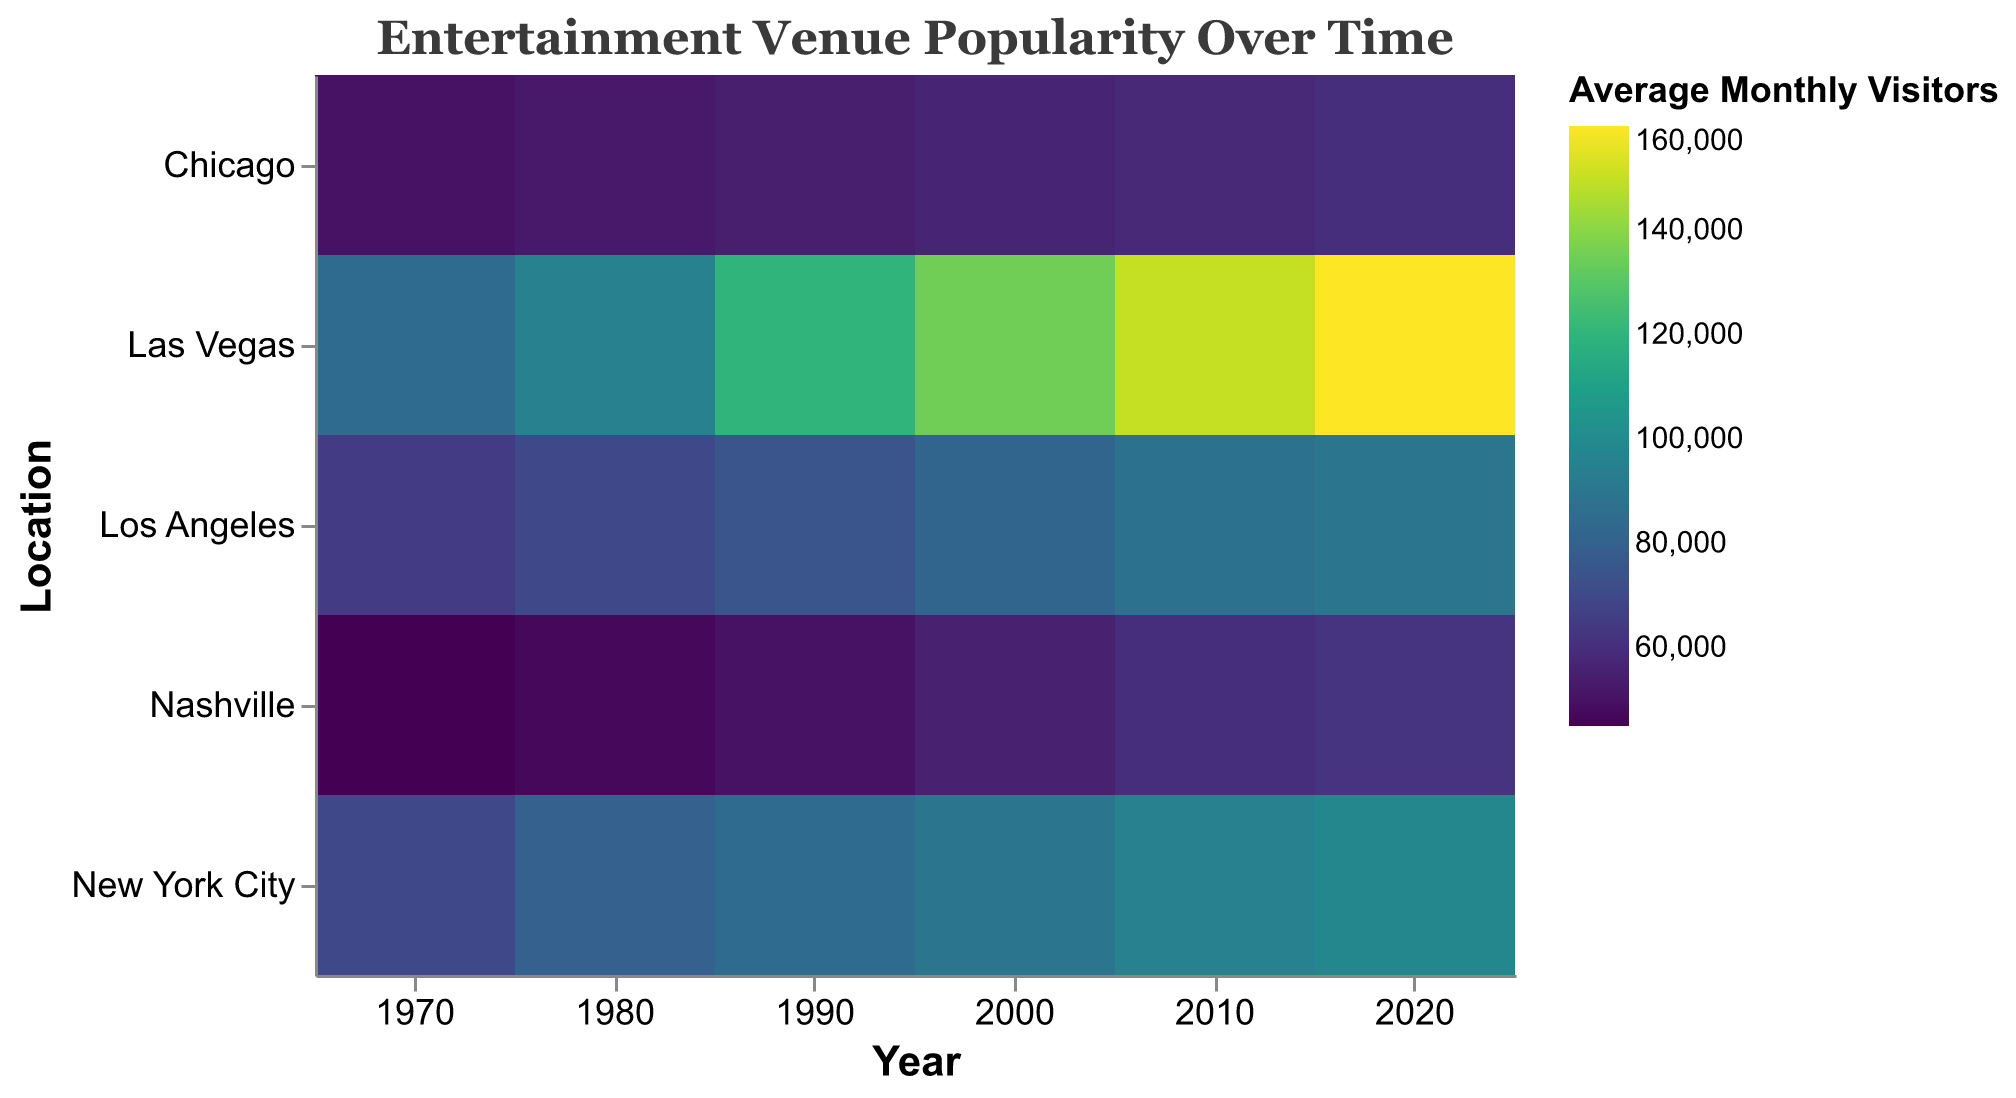How many geographic locations are represented in the heatmap? The heatmap shows rows labeled by geographic location, giving us the total number.
Answer: 5 What was the average monthly visitor count for Concert Venues in Los Angeles in 2010? Check the row for Los Angeles and the column for 2010, then identify the color intensity and corresponding visitor count in the legend.
Answer: 88,000 Which location had the highest increase in average monthly visitors from 1970 to 2020? Calculate the difference in average monthly visitors for each location from 1970 to 2020 and compare them.
Answer: Las Vegas Between New York City and Chicago, which location had more visitors in 1980? Compare the average monthly visitors for New York City and Chicago in the column for 1980.
Answer: New York City What pattern do you observe in the visitor numbers for Comedy Clubs in Chicago over the years? Look at the row for Chicago and observe the color gradient from 1970 to 2020.
Answer: Steady increase For which year and location did the Casino type venue have the highest average monthly visitors? Look for the highest value in the Las Vegas row, which is the only location with Casinos.
Answer: Las Vegas, 2020 What is the average increase in average monthly visitors for theaters in New York City from 1970 to 2020? Calculate the increase for each decade, add them up and divide by the number of decades. (80000−70000 + 85000−80000 + 90000−85000 + 95000−90000 + 98000−95000)/5 = 5600
Answer: 5,600 Compare the visitor trends of Concert Halls in Nashville and Concert Venues in Los Angeles. Do they show a similar pattern of increase? Observe the color gradients for Nashville's Concert Halls and Los Angeles's Concert Venues from 1970 to 2020 and compare the incremental changes.
Answer: No, Los Angeles shows a steeper increase Which venue type had a visitor count closest to 60,000 in the year 2010? Check all the rows for the year 2010 and focus on the color gradients closest to 60,000 in the legend.
Answer: Comedy Club in Chicago (58,000) What is the overall trend for venue popularity over time across all locations and venue types? Observe the change of color intensities from 1970 to 2020 across the entire heatmap.
Answer: Increasing trend 